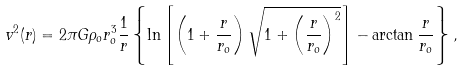Convert formula to latex. <formula><loc_0><loc_0><loc_500><loc_500>v ^ { 2 } ( r ) = 2 \pi G \rho _ { o } r _ { o } ^ { 3 } \frac { 1 } { r } \left \{ \ln { \left [ \left ( 1 + \frac { r } { r _ { o } } \right ) \sqrt { 1 + \left ( \frac { r } { r _ { o } } \right ) ^ { 2 } } \right ] } - \arctan { \frac { r } { r _ { o } } } \right \} ,</formula> 